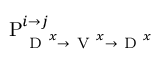Convert formula to latex. <formula><loc_0><loc_0><loc_500><loc_500>P _ { D ^ { x } \rightarrow V ^ { x } \rightarrow D ^ { x } } ^ { i \rightarrow j }</formula> 